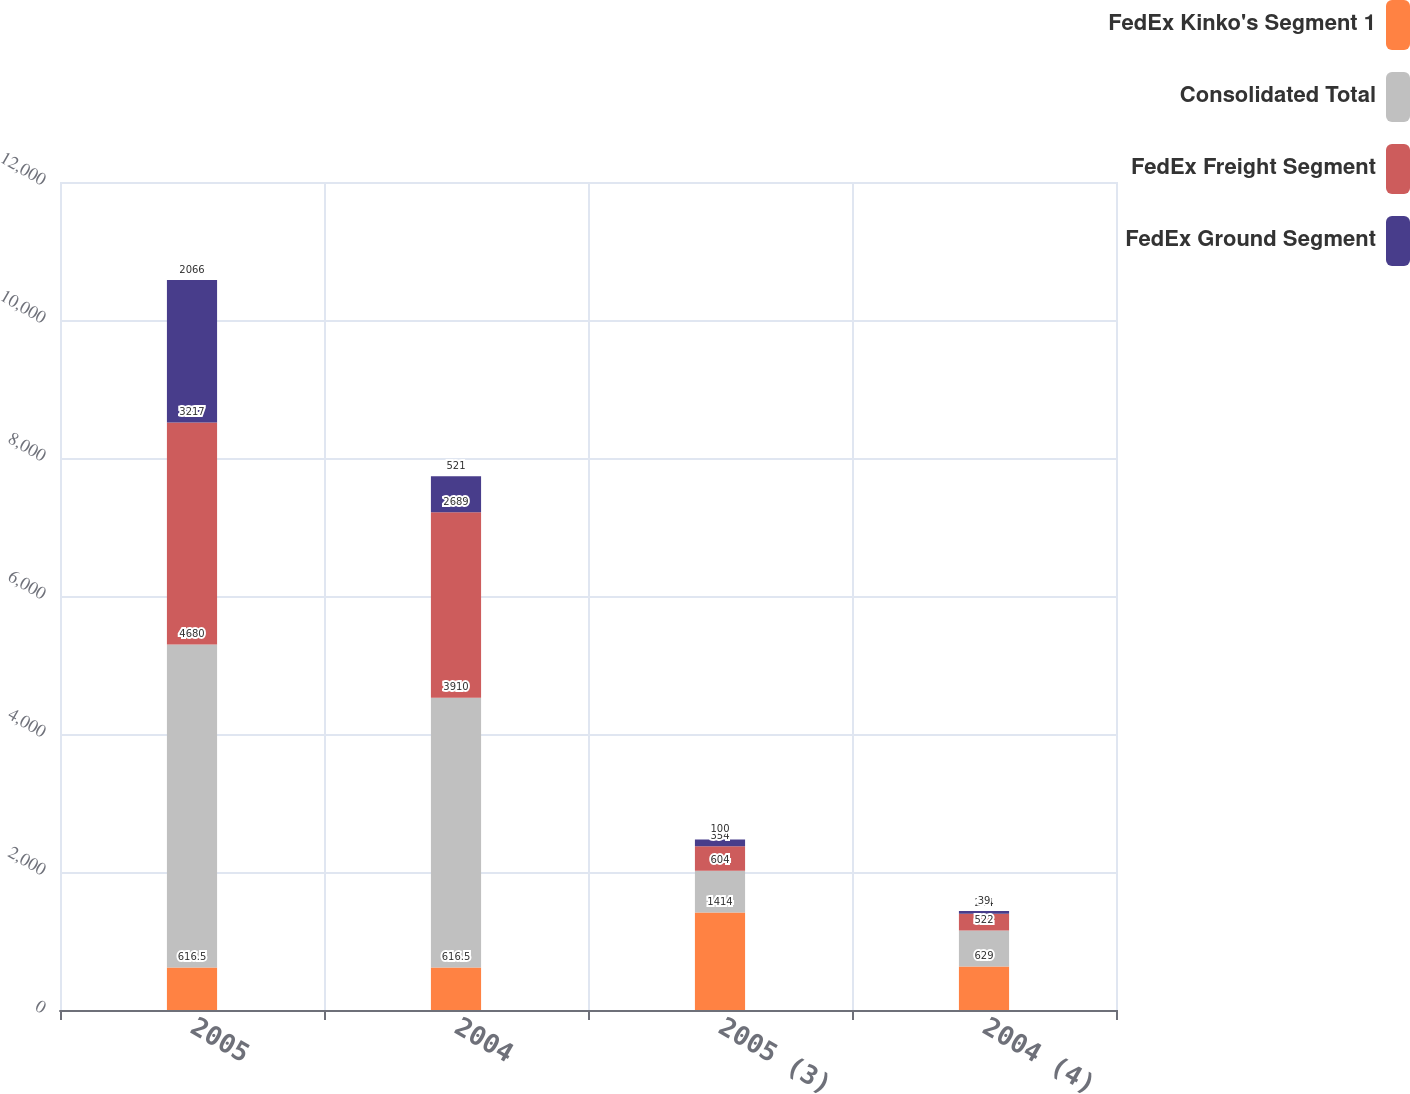Convert chart. <chart><loc_0><loc_0><loc_500><loc_500><stacked_bar_chart><ecel><fcel>2005<fcel>2004<fcel>2005 (3)<fcel>2004 (4)<nl><fcel>FedEx Kinko's Segment 1<fcel>616.5<fcel>616.5<fcel>1414<fcel>629<nl><fcel>Consolidated Total<fcel>4680<fcel>3910<fcel>604<fcel>522<nl><fcel>FedEx Freight Segment<fcel>3217<fcel>2689<fcel>354<fcel>244<nl><fcel>FedEx Ground Segment<fcel>2066<fcel>521<fcel>100<fcel>39<nl></chart> 